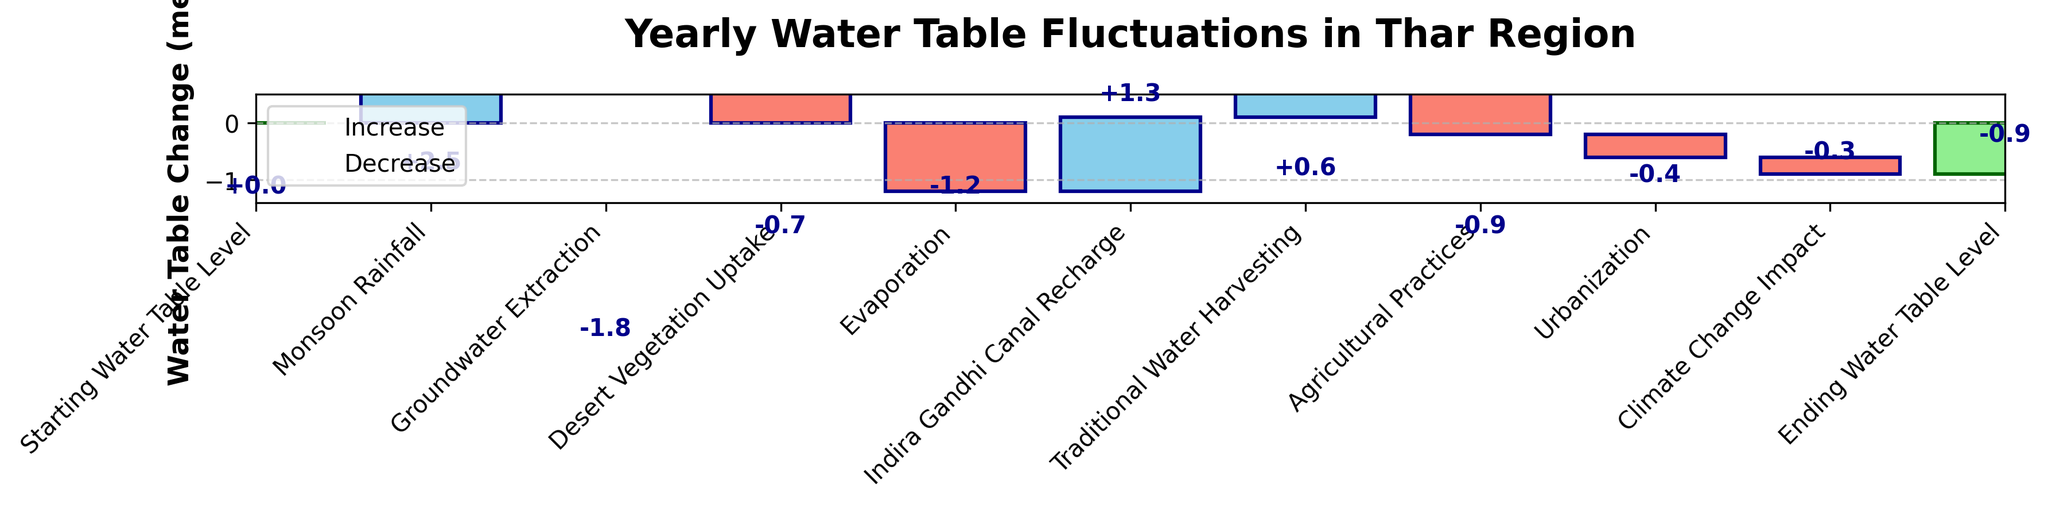What is the title of the figure? The title is the text displayed at the top of the figure. It describes the main topic or content of the chart.
Answer: Yearly Water Table Fluctuations in Thar Region What is the value of groundwater extraction? Find the category "Groundwater Extraction" in the x-axis labels. Directly above it, the bar indicating the change is colored in red, showing a numerical label.
Answer: -1.8 Which factor caused the highest increase in the water table? Look for the bar with the highest positive value among the categories. Compare each increment value to determine which is the largest.
Answer: Monsoon Rainfall What is the total decrease due to vegetation uptake and evaporation combined? Find the values for "Desert Vegetation Uptake" and "Evaporation" categories, both are decreases. Sum these values (-0.7 and -1.2).
Answer: -1.9 How much does urbanization affect the water table compared to traditional water harvesting? Compare the absolute values of the impacts indicated by the corresponding bars.
Answer: Urbanization: -0.4, Traditional Water Harvesting: +0.6 What is the net effect of monsoon rainfall and Indira Gandhi canal recharge combined? Add the values for "Monsoon Rainfall" (+2.5) and "Indira Gandhi Canal Recharge" (+1.3).
Answer: 3.8 Which factor has the smallest impact on the water table? Identify the category with the smallest absolute value in its bar label.
Answer: Climate Change Impact How does agricultural practices' impact compare to traditional water harvesting? Compare the numerical values of "Agricultural Practices" and "Traditional Water Harvesting" from the bars.
Answer: Agricultural Practices: -0.9, Traditional Water Harvesting: +0.6 What is the net change in the water table after all factors are considered? Look at the final value labeled "Ending Water Table Level."
Answer: -0.9 How much does groundwater extraction combined with agricultural practices decrease the water table? Sum the impacts of "Groundwater Extraction" (-1.8) and "Agricultural Practices" (-0.9).
Answer: -2.7 